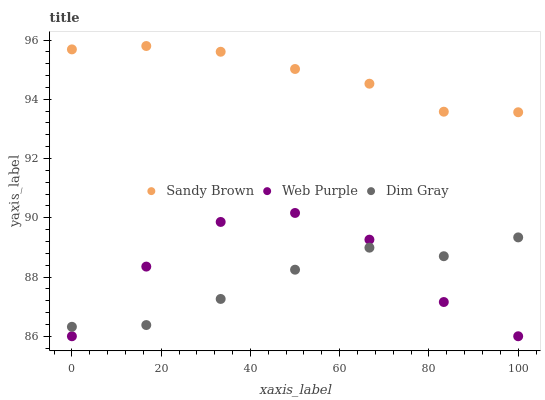Does Dim Gray have the minimum area under the curve?
Answer yes or no. Yes. Does Sandy Brown have the maximum area under the curve?
Answer yes or no. Yes. Does Sandy Brown have the minimum area under the curve?
Answer yes or no. No. Does Dim Gray have the maximum area under the curve?
Answer yes or no. No. Is Sandy Brown the smoothest?
Answer yes or no. Yes. Is Web Purple the roughest?
Answer yes or no. Yes. Is Dim Gray the smoothest?
Answer yes or no. No. Is Dim Gray the roughest?
Answer yes or no. No. Does Web Purple have the lowest value?
Answer yes or no. Yes. Does Dim Gray have the lowest value?
Answer yes or no. No. Does Sandy Brown have the highest value?
Answer yes or no. Yes. Does Dim Gray have the highest value?
Answer yes or no. No. Is Web Purple less than Sandy Brown?
Answer yes or no. Yes. Is Sandy Brown greater than Dim Gray?
Answer yes or no. Yes. Does Web Purple intersect Dim Gray?
Answer yes or no. Yes. Is Web Purple less than Dim Gray?
Answer yes or no. No. Is Web Purple greater than Dim Gray?
Answer yes or no. No. Does Web Purple intersect Sandy Brown?
Answer yes or no. No. 